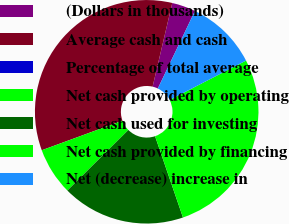Convert chart. <chart><loc_0><loc_0><loc_500><loc_500><pie_chart><fcel>(Dollars in thousands)<fcel>Average cash and cash<fcel>Percentage of total average<fcel>Net cash provided by operating<fcel>Net cash used for investing<fcel>Net cash provided by financing<fcel>Net (decrease) increase in<nl><fcel>3.43%<fcel>34.27%<fcel>0.0%<fcel>6.85%<fcel>17.82%<fcel>27.31%<fcel>10.32%<nl></chart> 